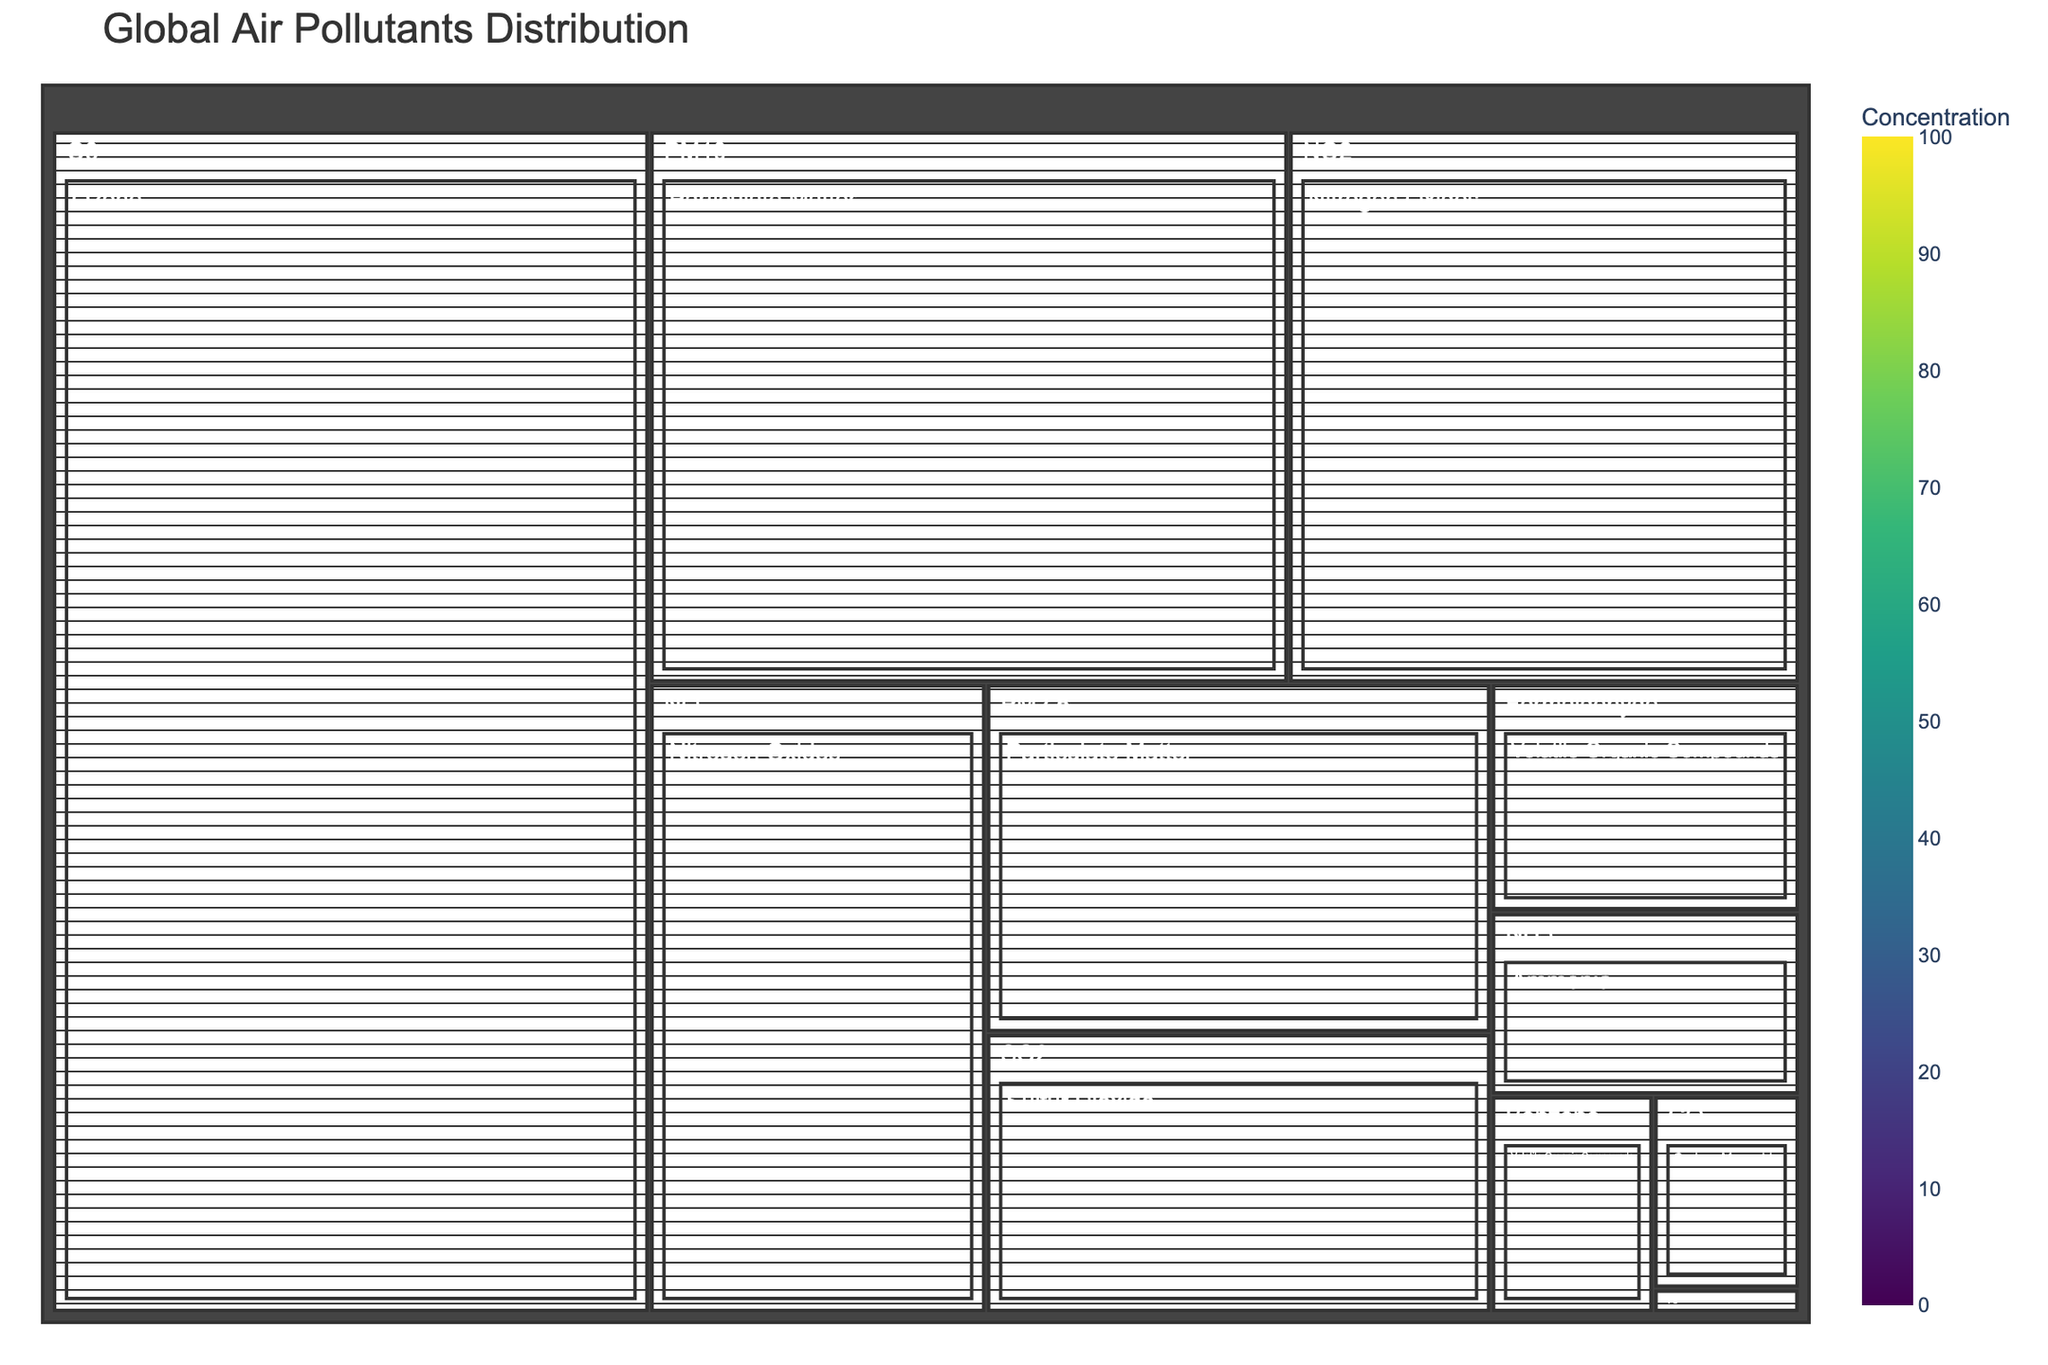What's the title of the figure? The title is typically displayed at the top of the figure. In this case, it is specified in the code provided. The title is "Global Air Pollutants Distribution".
Answer: Global Air Pollutants Distribution How many different types of pollutants are displayed? The tree map groups pollutants by type, and the types can be found within the path specified. There are 7 unique pollutant types listed in the data: Particulate Matter, Nitrogen Oxides, Ozone, Sulfur Dioxide, Carbon Monoxide, Volatile Organic Compounds, Lead, Ammonia, and Polycyclic Aromatic Hydrocarbons.
Answer: 7 Which pollutant has the highest concentration? By looking at the concentration levels in the treemap, the pollutant with the highest concentration value will be the one with the largest or most prominently colored block. From the data, Ozone (O3) has a concentration of 100, the highest listed.
Answer: Ozone What are the concentrations of PM2.5 and PM10? The treemap shows individual pollutants and their concentrations within their types. For Particulate Matter, PM2.5 has a concentration of 25, and PM10 has a concentration of 50.
Answer: PM2.5: 25, PM10: 50 Which category has the smallest concentration value, and what is it? By examining the treemap, we can locate the smallest block or the faintest color. From the data, this is Polycyclic Aromatic Hydrocarbons categorized as Benzo(a)pyrene with a concentration of 0.001.
Answer: Polycyclic Aromatic Hydrocarbons (Benzo(a)pyrene) What's the total concentration of pollutants under Nitrogen Oxides? To find this, sum up the concentration values of pollutants under Nitrogen Oxides. NO2 has a concentration of 40 and NO has a concentration of 30. Thus, the total concentration is 40 + 30 = 70.
Answer: 70 Compare the concentration levels of Sulfur Dioxide and Ammonia. Which one is higher? By looking at the treemap and finding the corresponding blocks for each pollutant, we can compare their concentrations: Sulfur Dioxide (SO2) has a concentration of 20, while Ammonia (NH3) has a concentration of 8. Sulfur Dioxide has a higher concentration.
Answer: Sulfur Dioxide Rank the pollutants under Volatile Organic Compounds by their concentration levels. Within the Volatile Organic Compounds type, examine the concentration values of Benzene and Formaldehyde. Benzene has a concentration of 5, and Formaldehyde has a concentration of 10. Ranking them: Formaldehyde > Benzene.
Answer: Formaldehyde, Benzene What's the difference in concentration between Carbon Monoxide and Lead? Identify the concentration values for Carbon Monoxide (4) and Lead (0.5). Find the difference: 4 - 0.5 = 3.5.
Answer: 3.5 What is the average concentration of pollutants listed in the treemap? Calculate the total sum of all concentration values and then divide by the total number of pollutants. The sum is: 25 + 50 + 40 + 30 + 100 + 20 + 4 + 5 + 10 + 0.5 + 8 + 0.001 = 292.501. The number of pollutants is 12, so the average is 292.501 / 12 ≈ 24.38.
Answer: 24.38 